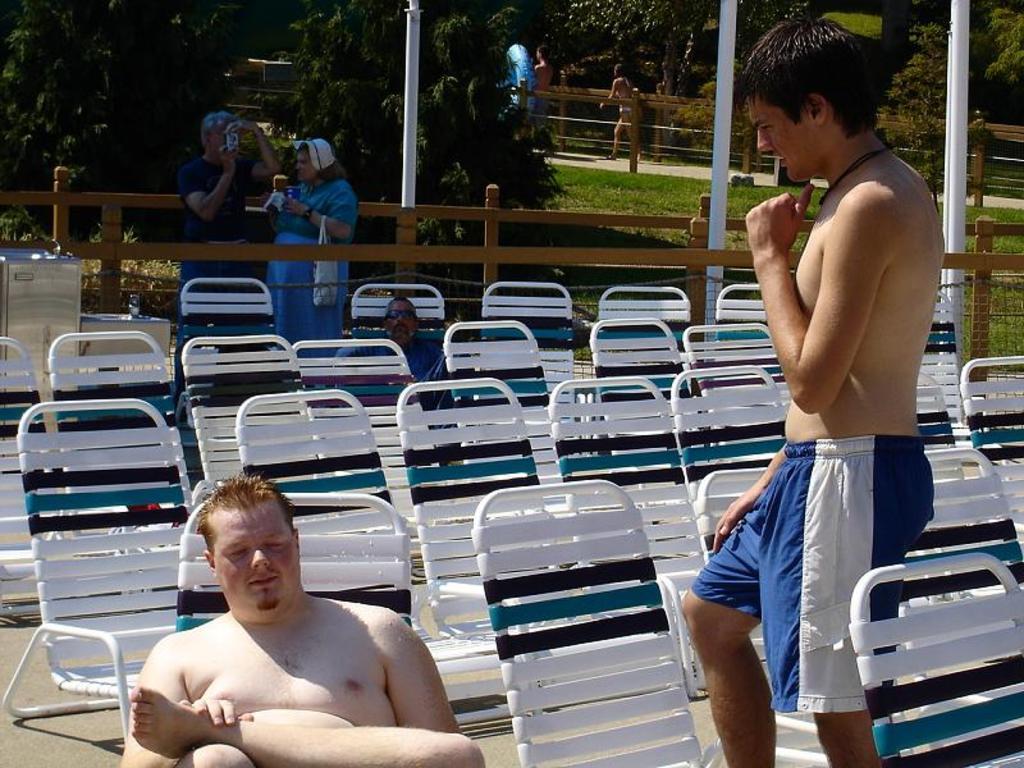Can you describe this image briefly? In the foreground of the picture there are people and chairs. In the center of the picture there are trees, grass, railing, poles and people. In the background there are people and trees. 